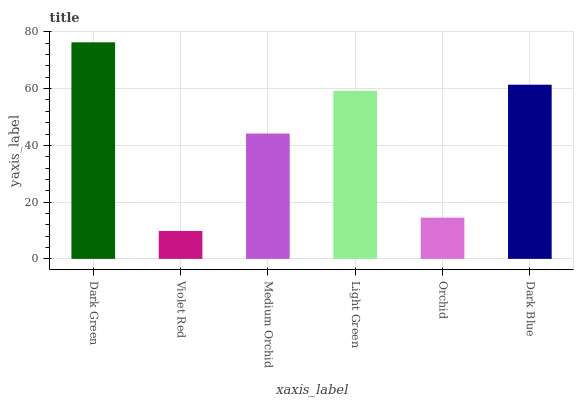Is Violet Red the minimum?
Answer yes or no. Yes. Is Dark Green the maximum?
Answer yes or no. Yes. Is Medium Orchid the minimum?
Answer yes or no. No. Is Medium Orchid the maximum?
Answer yes or no. No. Is Medium Orchid greater than Violet Red?
Answer yes or no. Yes. Is Violet Red less than Medium Orchid?
Answer yes or no. Yes. Is Violet Red greater than Medium Orchid?
Answer yes or no. No. Is Medium Orchid less than Violet Red?
Answer yes or no. No. Is Light Green the high median?
Answer yes or no. Yes. Is Medium Orchid the low median?
Answer yes or no. Yes. Is Medium Orchid the high median?
Answer yes or no. No. Is Dark Blue the low median?
Answer yes or no. No. 